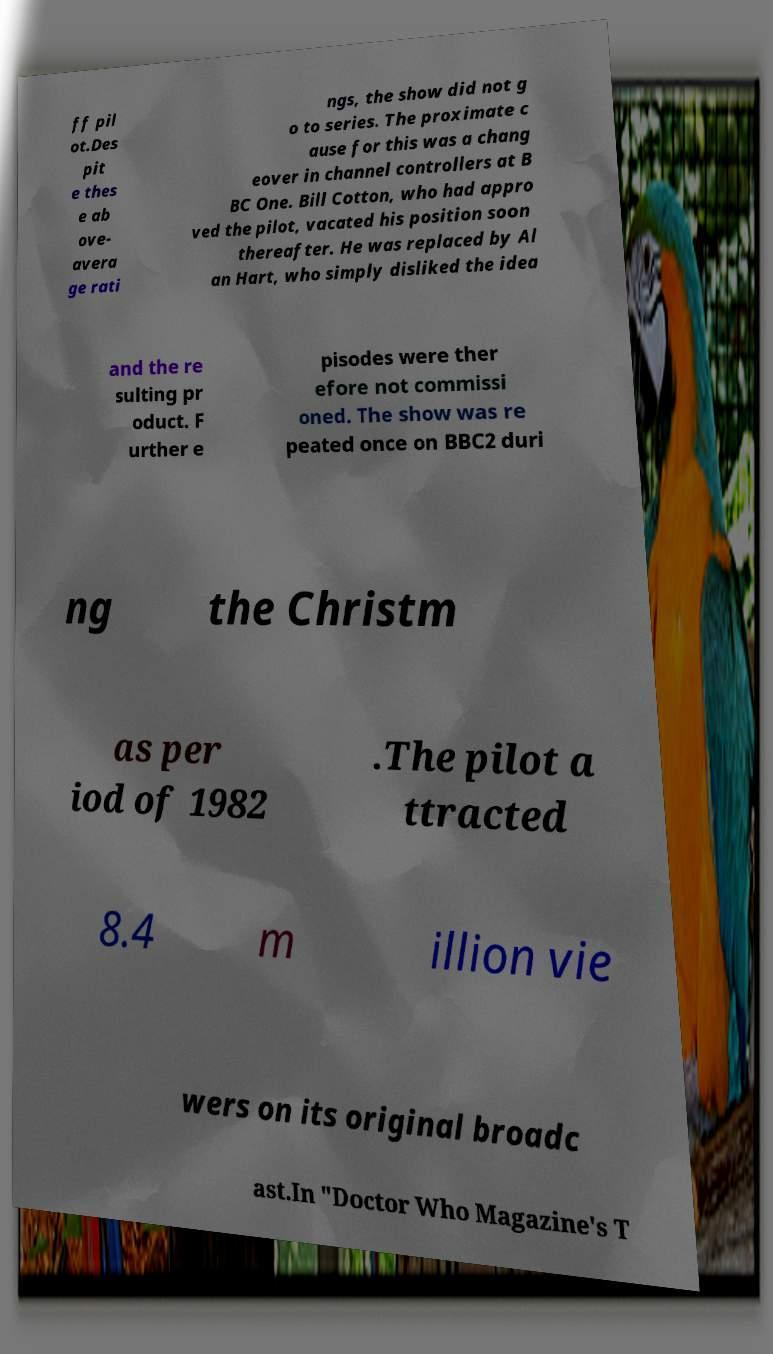What messages or text are displayed in this image? I need them in a readable, typed format. ff pil ot.Des pit e thes e ab ove- avera ge rati ngs, the show did not g o to series. The proximate c ause for this was a chang eover in channel controllers at B BC One. Bill Cotton, who had appro ved the pilot, vacated his position soon thereafter. He was replaced by Al an Hart, who simply disliked the idea and the re sulting pr oduct. F urther e pisodes were ther efore not commissi oned. The show was re peated once on BBC2 duri ng the Christm as per iod of 1982 .The pilot a ttracted 8.4 m illion vie wers on its original broadc ast.In "Doctor Who Magazine's T 